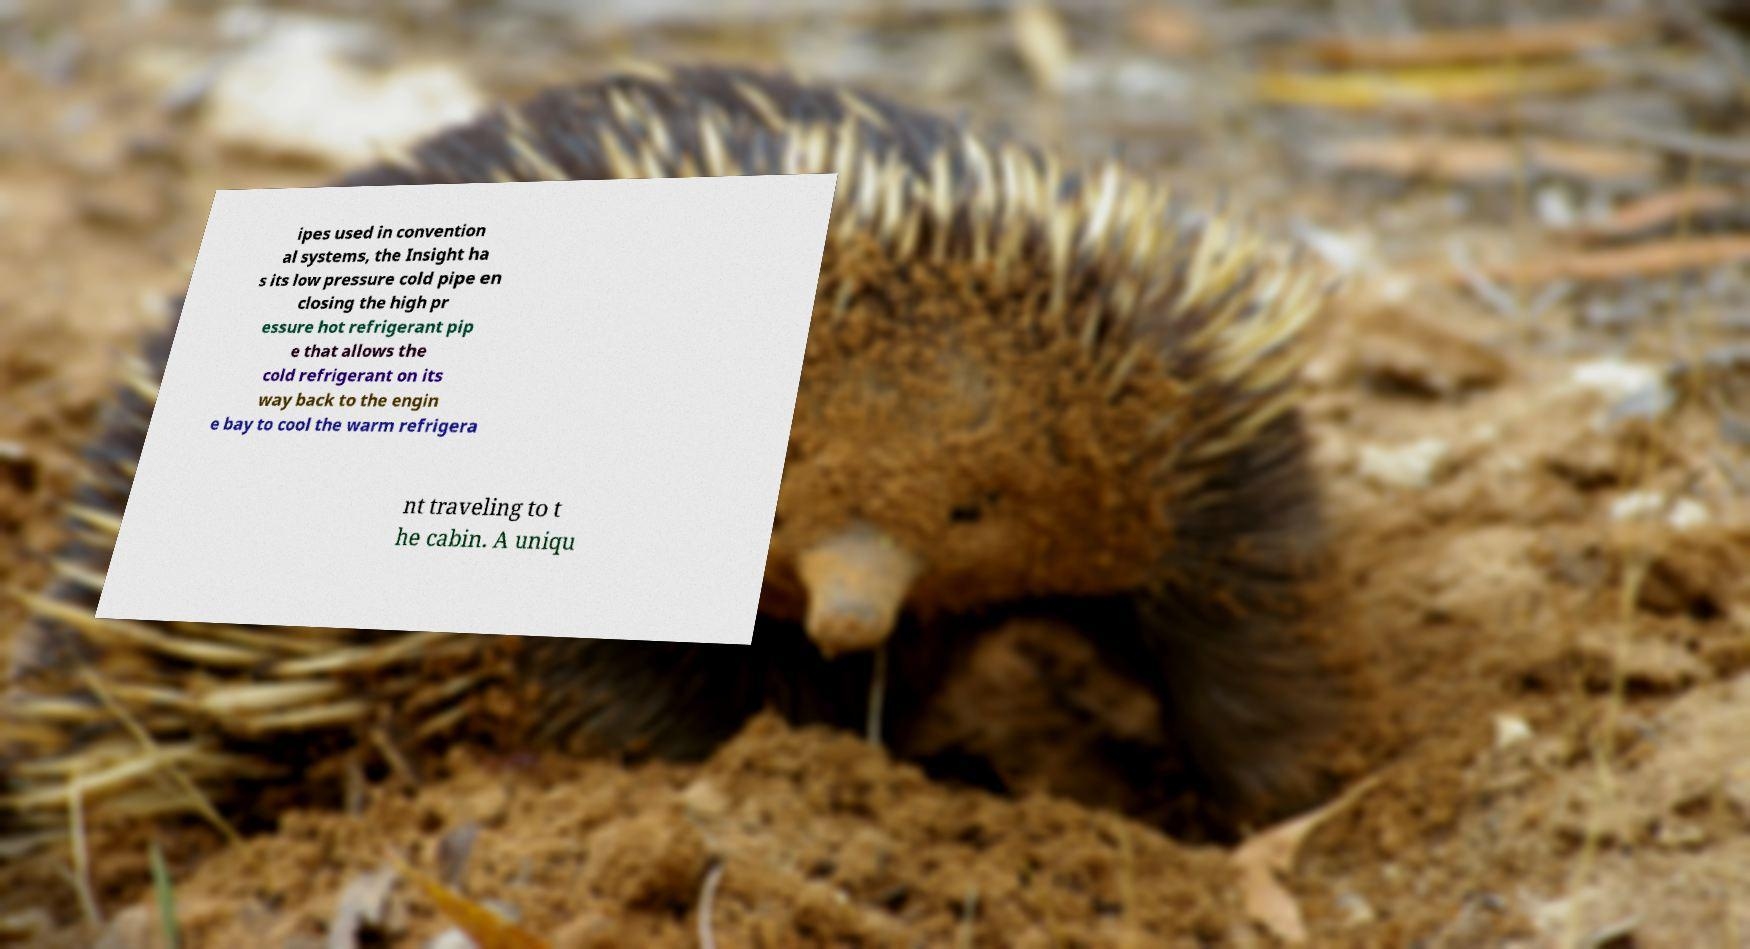Please identify and transcribe the text found in this image. ipes used in convention al systems, the Insight ha s its low pressure cold pipe en closing the high pr essure hot refrigerant pip e that allows the cold refrigerant on its way back to the engin e bay to cool the warm refrigera nt traveling to t he cabin. A uniqu 